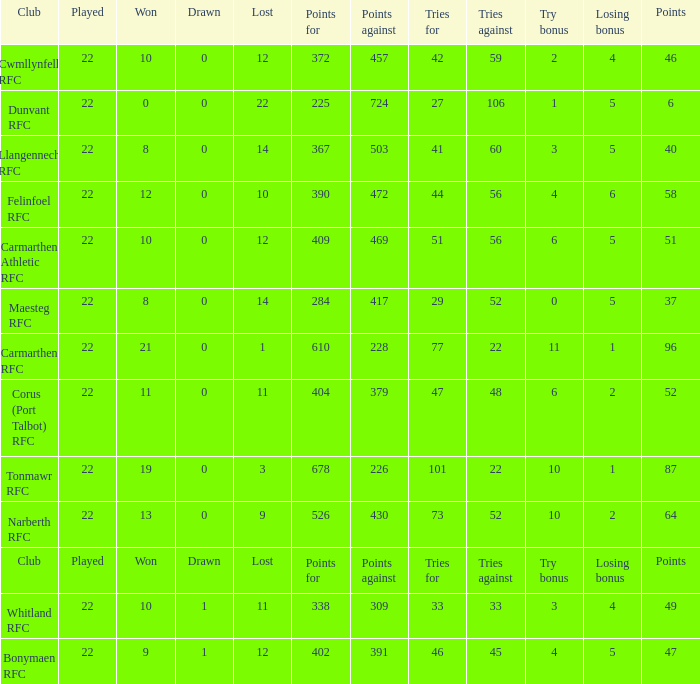Name the losing bonus of 96 points 1.0. 